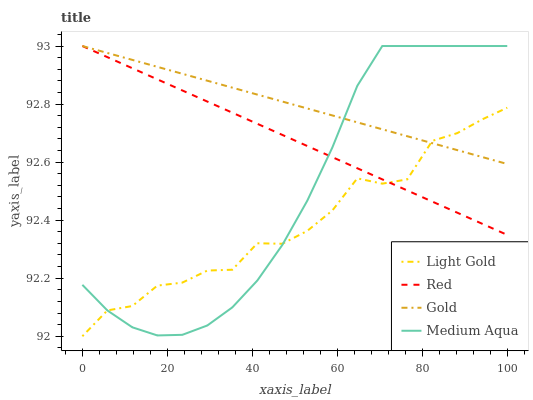Does Light Gold have the minimum area under the curve?
Answer yes or no. Yes. Does Gold have the maximum area under the curve?
Answer yes or no. Yes. Does Gold have the minimum area under the curve?
Answer yes or no. No. Does Light Gold have the maximum area under the curve?
Answer yes or no. No. Is Gold the smoothest?
Answer yes or no. Yes. Is Light Gold the roughest?
Answer yes or no. Yes. Is Light Gold the smoothest?
Answer yes or no. No. Is Gold the roughest?
Answer yes or no. No. Does Light Gold have the lowest value?
Answer yes or no. Yes. Does Gold have the lowest value?
Answer yes or no. No. Does Red have the highest value?
Answer yes or no. Yes. Does Light Gold have the highest value?
Answer yes or no. No. Does Light Gold intersect Red?
Answer yes or no. Yes. Is Light Gold less than Red?
Answer yes or no. No. Is Light Gold greater than Red?
Answer yes or no. No. 